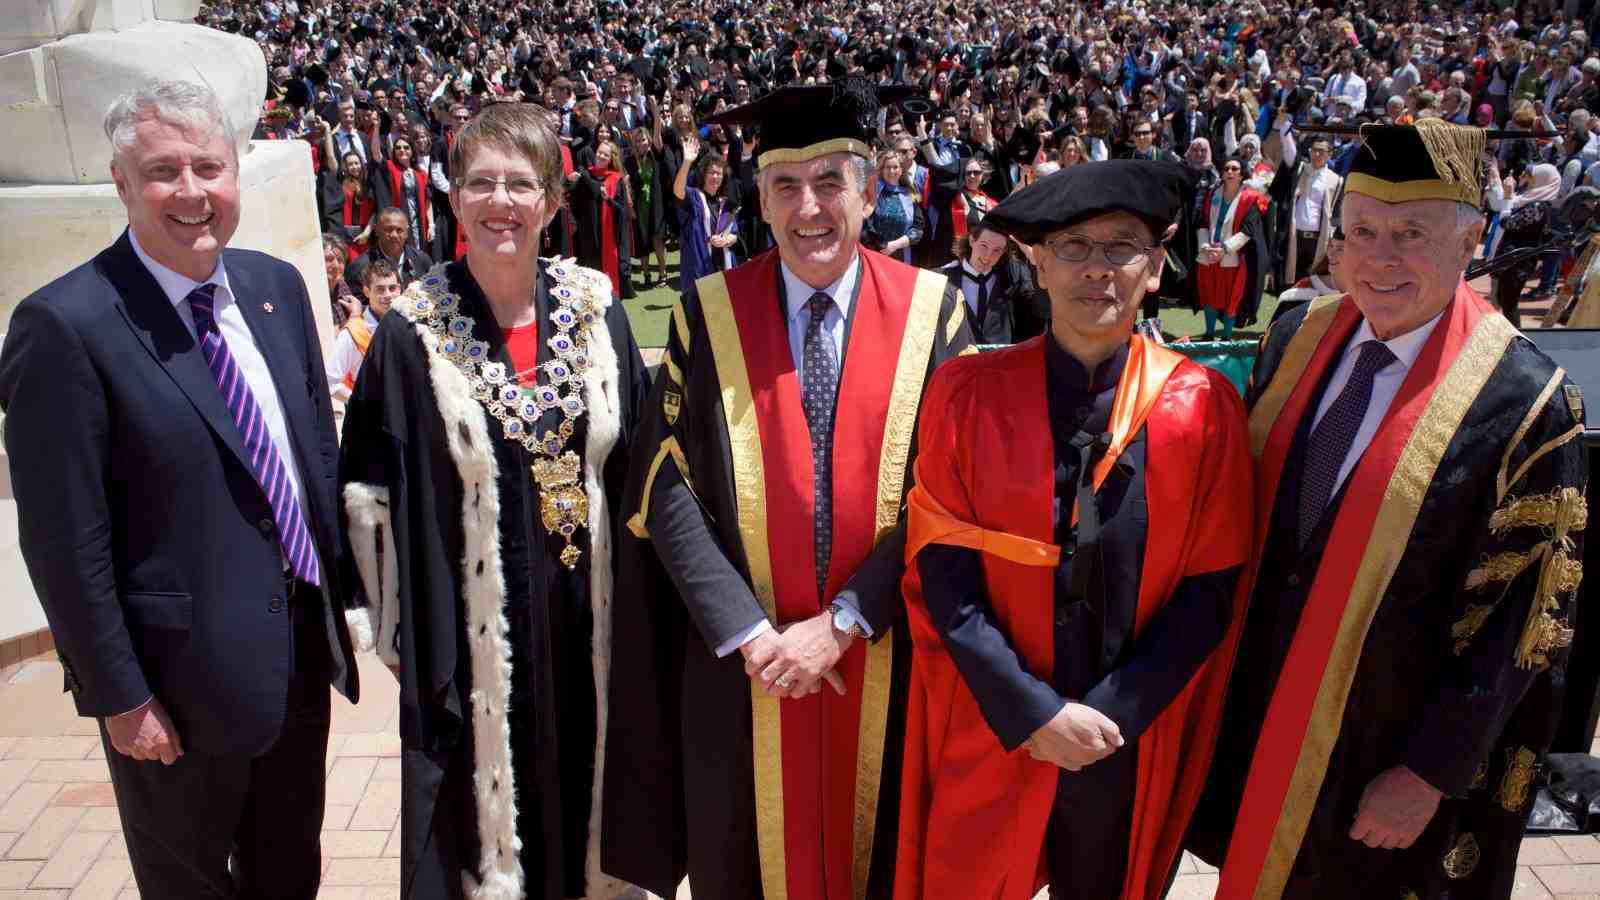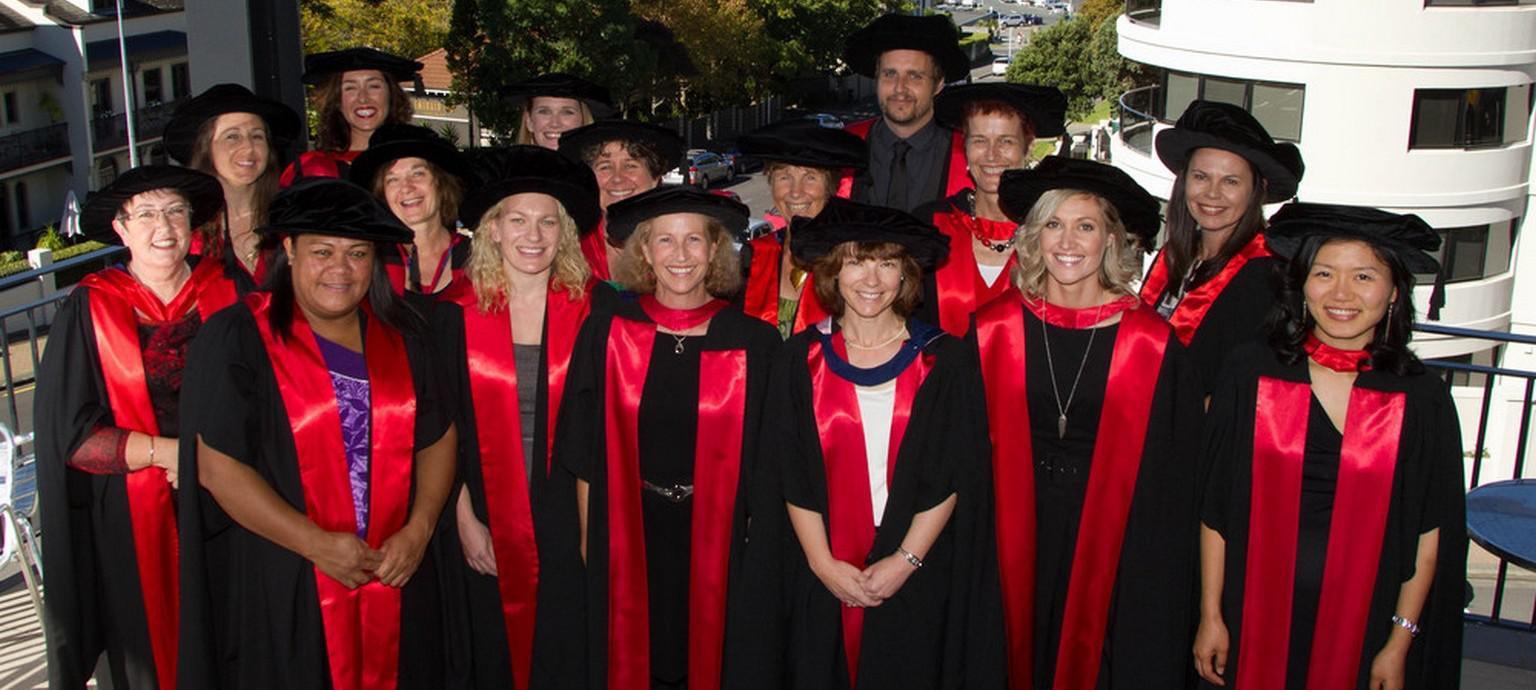The first image is the image on the left, the second image is the image on the right. Analyze the images presented: Is the assertion "Everyone in the image on the right is wearing a red stole." valid? Answer yes or no. Yes. The first image is the image on the left, the second image is the image on the right. Given the left and right images, does the statement "At least one image includes multiple people wearing red sashes and a non-traditional graduation black cap." hold true? Answer yes or no. Yes. 